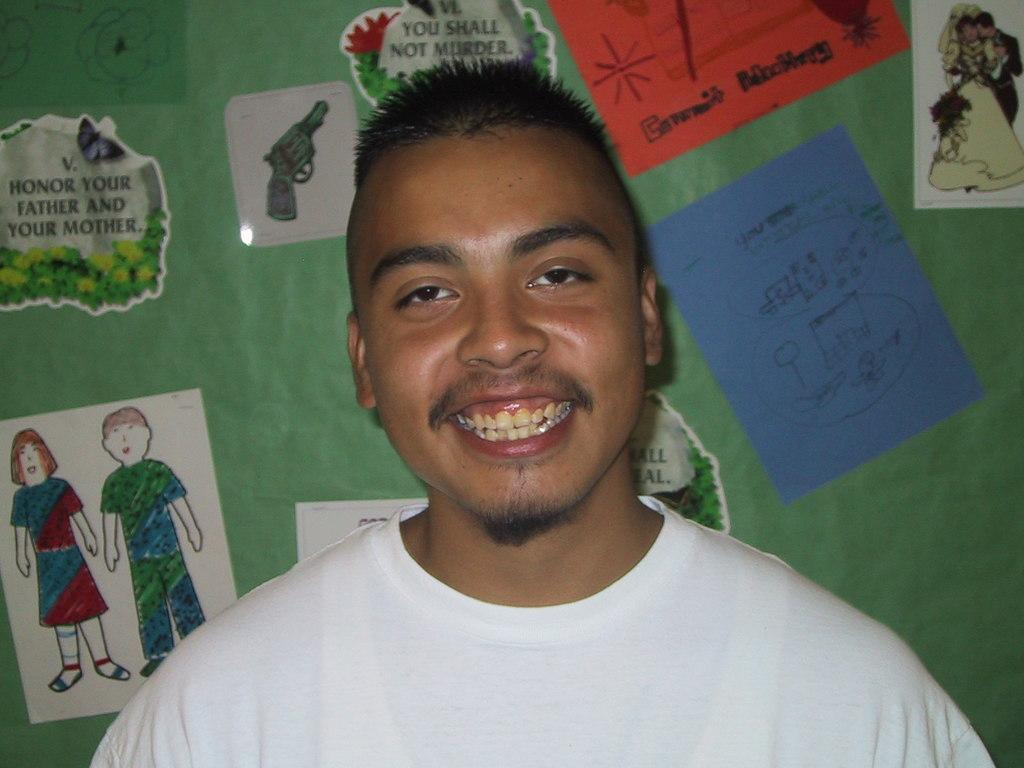Who is present in the image? There is a man in the image. What can be seen on the wall in the image? There are papers pasted on a wall in the image. What do the papers contain? The papers contain pictures and text. What type of shoes is the man wearing for breakfast in the image? There is no mention of shoes or breakfast in the image, and the man's footwear is not visible. 